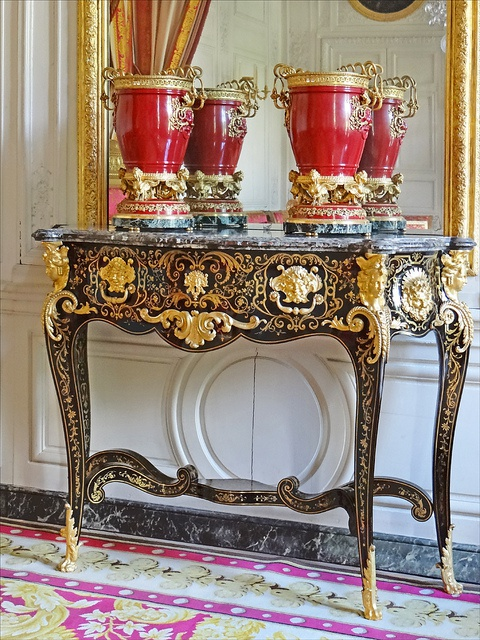Describe the objects in this image and their specific colors. I can see vase in gray, brown, maroon, and ivory tones, vase in gray, brown, ivory, and maroon tones, vase in gray, maroon, brown, and tan tones, and vase in gray, brown, darkgray, and maroon tones in this image. 